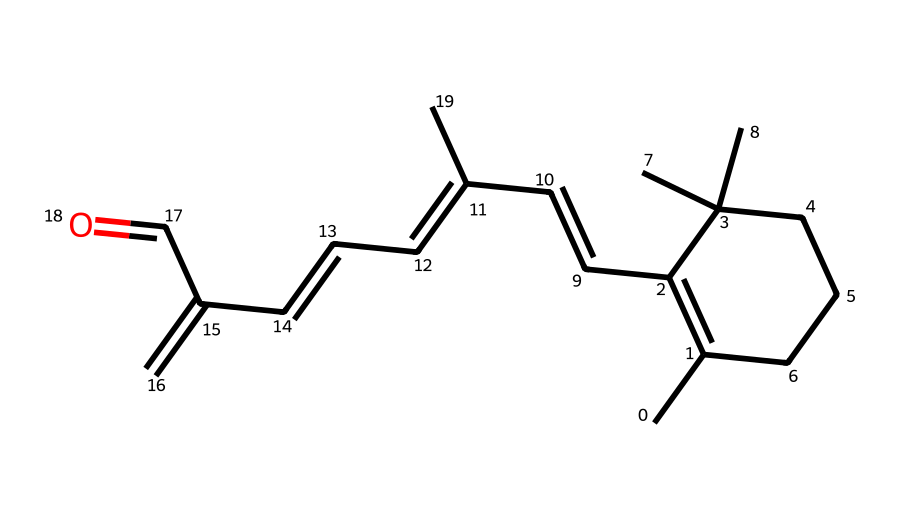What is the molecular formula of vitamin A based on this structure? To determine the molecular formula, we count the number of carbon (C), hydrogen (H), and oxygen (O) atoms in the SMILES representation. The structure contains 27 carbon atoms, 42 hydrogen atoms, and 1 oxygen atom. Therefore, the molecular formula is C27H42O.
Answer: C27H42O How many double bonds are present in the structure? By analyzing the structure represented in the SMILES, we can identify the presence of double bonds by looking for instances of "C=C" and accounting for their locations. In the given SMILES, there are 5 double bonds in total.
Answer: 5 What specific role does vitamin A play in color perception? Vitamin A is essential for the synthesis of visual pigments in the retina, particularly rhodopsin, which is crucial for color perception, especially in low light conditions.
Answer: visual pigments Is vitamin A hydrophobic or hydrophilic? Given the carbon-rich structure of vitamin A, which comprises mainly of non-polar covalent bonds, it indicates low solubility in water and thus suggests that vitamin A is hydrophobic.
Answer: hydrophobic How many rings are in the molecular structure? Analyzing the SMILES representation, we can identify the cyclic structures present within the compound. In this structure, there is one cyclohexene ring visible within the entire molecule.
Answer: 1 What is the functional group present in this molecule? Upon examining the end of the structure, we see the presence of an aldehyde group (as indicated by the "=O" bonded to a carbon at the terminal position). This identifies the functional group present in this molecule.
Answer: aldehyde 